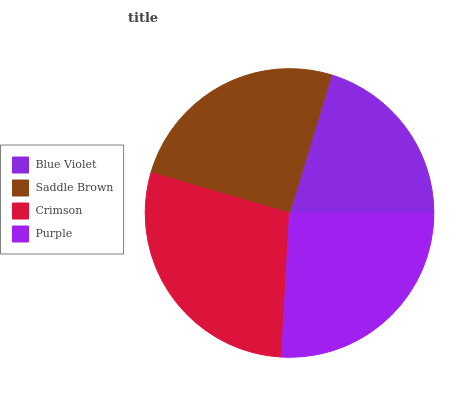Is Blue Violet the minimum?
Answer yes or no. Yes. Is Crimson the maximum?
Answer yes or no. Yes. Is Saddle Brown the minimum?
Answer yes or no. No. Is Saddle Brown the maximum?
Answer yes or no. No. Is Saddle Brown greater than Blue Violet?
Answer yes or no. Yes. Is Blue Violet less than Saddle Brown?
Answer yes or no. Yes. Is Blue Violet greater than Saddle Brown?
Answer yes or no. No. Is Saddle Brown less than Blue Violet?
Answer yes or no. No. Is Purple the high median?
Answer yes or no. Yes. Is Saddle Brown the low median?
Answer yes or no. Yes. Is Blue Violet the high median?
Answer yes or no. No. Is Purple the low median?
Answer yes or no. No. 